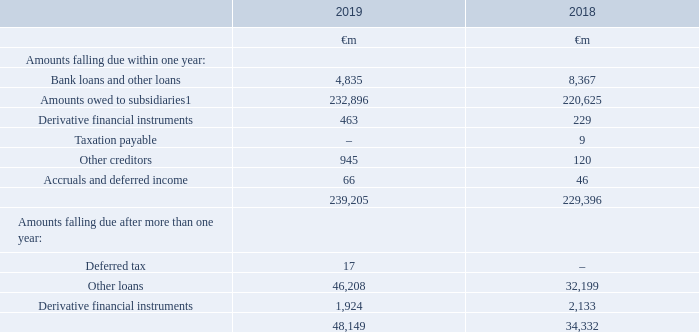5. Creditors
Accounting policies
Capital market and bank borrowings
Interest-bearing loans and overdrafts are initially measured at fair value (which is equal to cost at inception) and are subsequently measured at amortised cost using the effective interest rate method, except where they are identified as a hedged item in a designated hedge relationship. Any difference between the proceeds net of transaction costs and the amount due on settlement or redemption of borrowings is recognised over the term of the borrowing
Notes: 1 Amounts owed to subsidiaries are unsecured, have no fixed date of repayment and are repayable on demand.
Included in amounts falling due after more than one year are other loans of €31,157 million which are due in more than five years from 1 April 2019 and are payable otherwise than by instalments. Interest payable on these loans ranges from 0.375% to 7.875%.
Details of bond and other debt issuances are set out in note 20 “Borrowing and capital resources” in the consolidated financial statements
What financial items does amounts falling due within one year consist of? Bank loans and other loans, amounts owed to subsidiaries, derivative financial instruments, taxation payable, other creditors, accruals and deferred income. What financial items does amounts falling due after more than one year consist of? Deferred tax, other loans, derivative financial instruments. What is the 2019 average total amount falling due within one year ?
Answer scale should be: million. (239,205+229,396)/2
Answer: 234300.5. What is the 2019 amounts owed to subsidiaries within one year?
Answer scale should be: million. 232,896. What is the 2019 average total amounts falling due after more than one year ?
Answer scale should be: million. (48,149+34,332)/2
Answer: 41240.5. Which year has a higher amount of bank loans and other loans under amounts falling due within one year? 8,367 > 4,835
Answer: 2018. 